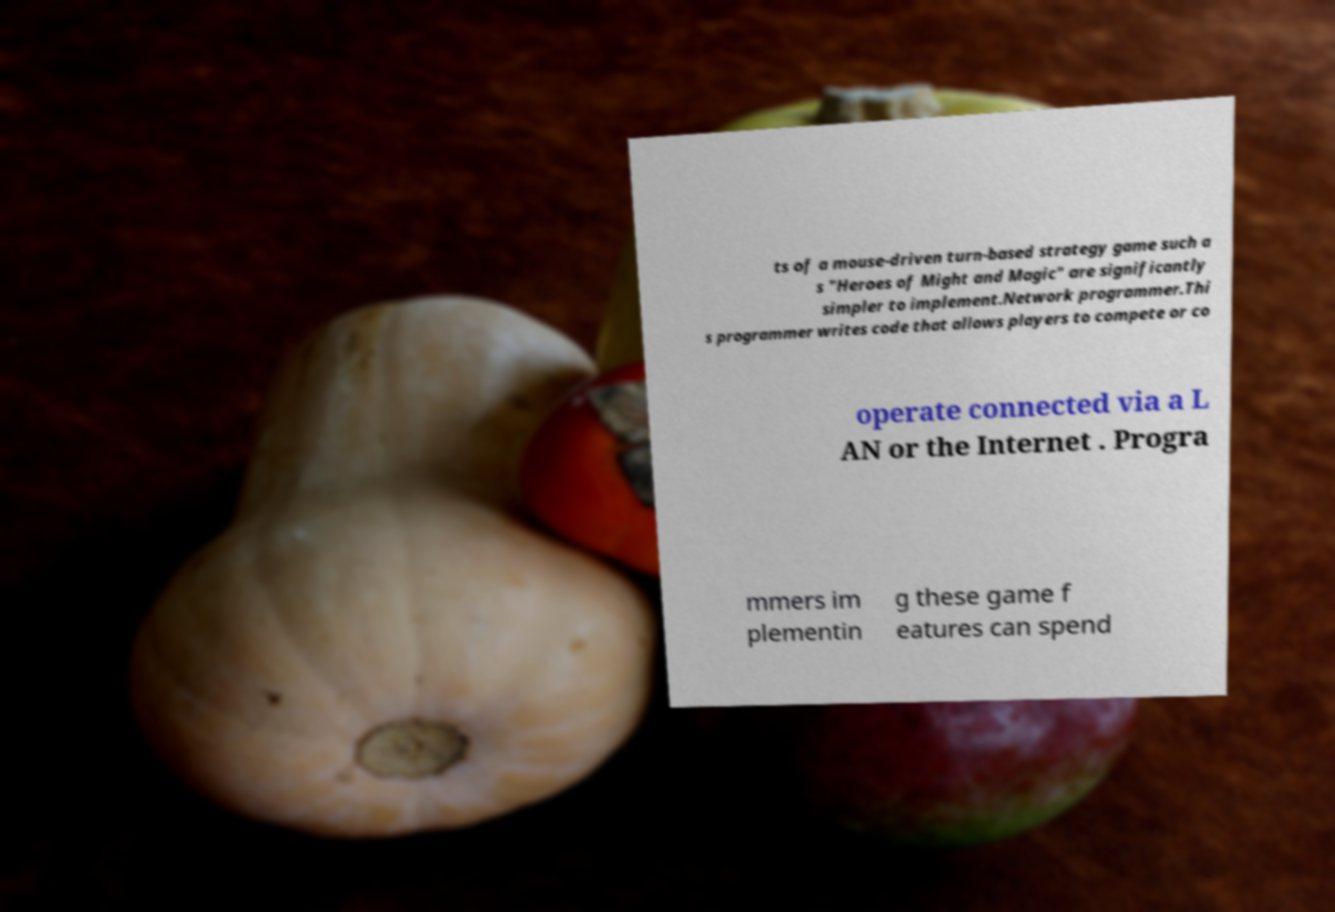Can you read and provide the text displayed in the image?This photo seems to have some interesting text. Can you extract and type it out for me? ts of a mouse-driven turn-based strategy game such a s "Heroes of Might and Magic" are significantly simpler to implement.Network programmer.Thi s programmer writes code that allows players to compete or co operate connected via a L AN or the Internet . Progra mmers im plementin g these game f eatures can spend 